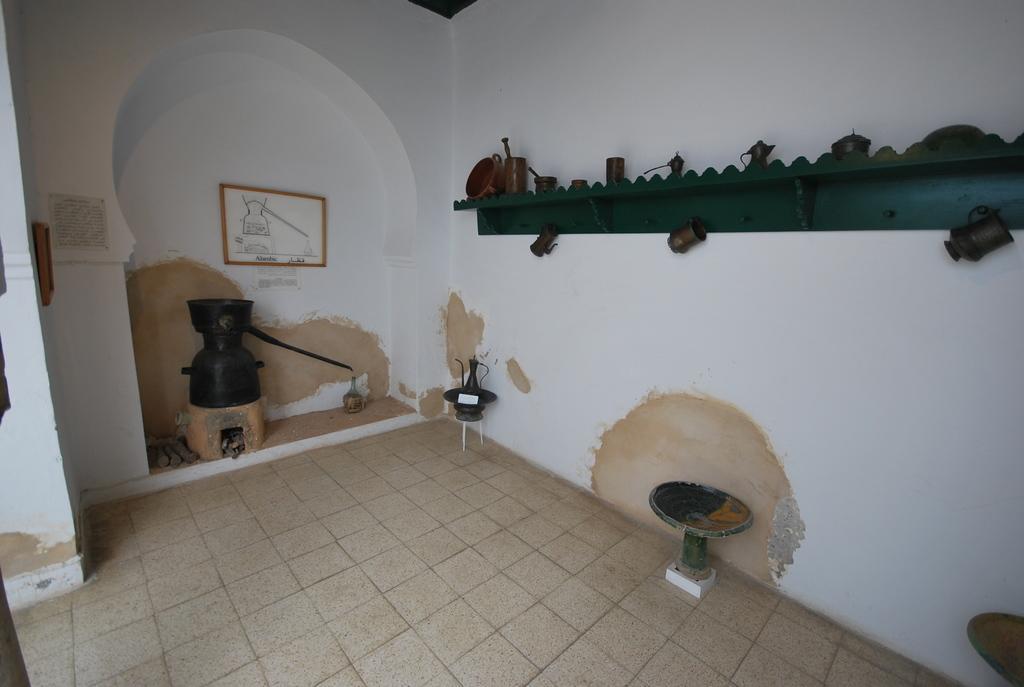How would you summarize this image in a sentence or two? In this image there are a few objects in a room, on the wall there is a photo frame and a wooden platform with some objects on it. 